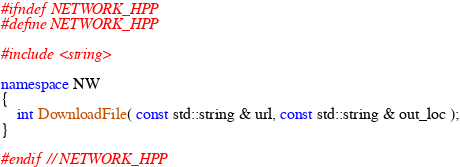<code> <loc_0><loc_0><loc_500><loc_500><_C++_>#ifndef NETWORK_HPP
#define NETWORK_HPP

#include <string>

namespace NW
{
	int DownloadFile( const std::string & url, const std::string & out_loc );
}

#endif // NETWORK_HPP</code> 